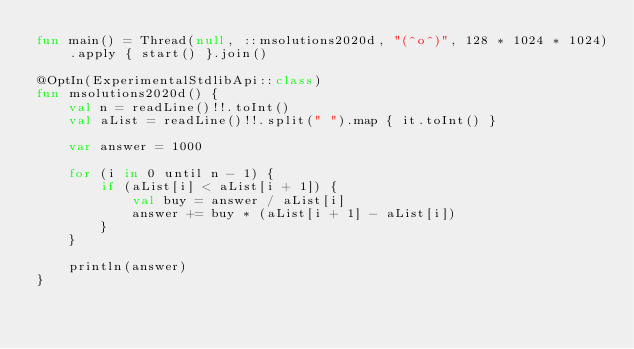Convert code to text. <code><loc_0><loc_0><loc_500><loc_500><_Kotlin_>fun main() = Thread(null, ::msolutions2020d, "(^o^)", 128 * 1024 * 1024).apply { start() }.join()

@OptIn(ExperimentalStdlibApi::class)
fun msolutions2020d() {
    val n = readLine()!!.toInt()
    val aList = readLine()!!.split(" ").map { it.toInt() }

    var answer = 1000

    for (i in 0 until n - 1) {
        if (aList[i] < aList[i + 1]) {
            val buy = answer / aList[i]
            answer += buy * (aList[i + 1] - aList[i])
        }
    }

    println(answer)
}
</code> 